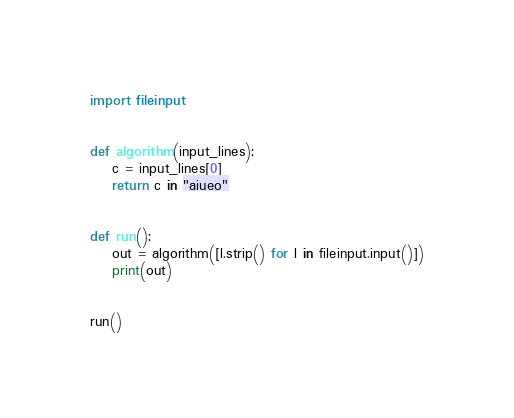Convert code to text. <code><loc_0><loc_0><loc_500><loc_500><_Python_>import fileinput


def algorithm(input_lines):
    c = input_lines[0]
    return c in "aiueo"


def run():
    out = algorithm([l.strip() for l in fileinput.input()])
    print(out)


run()
</code> 